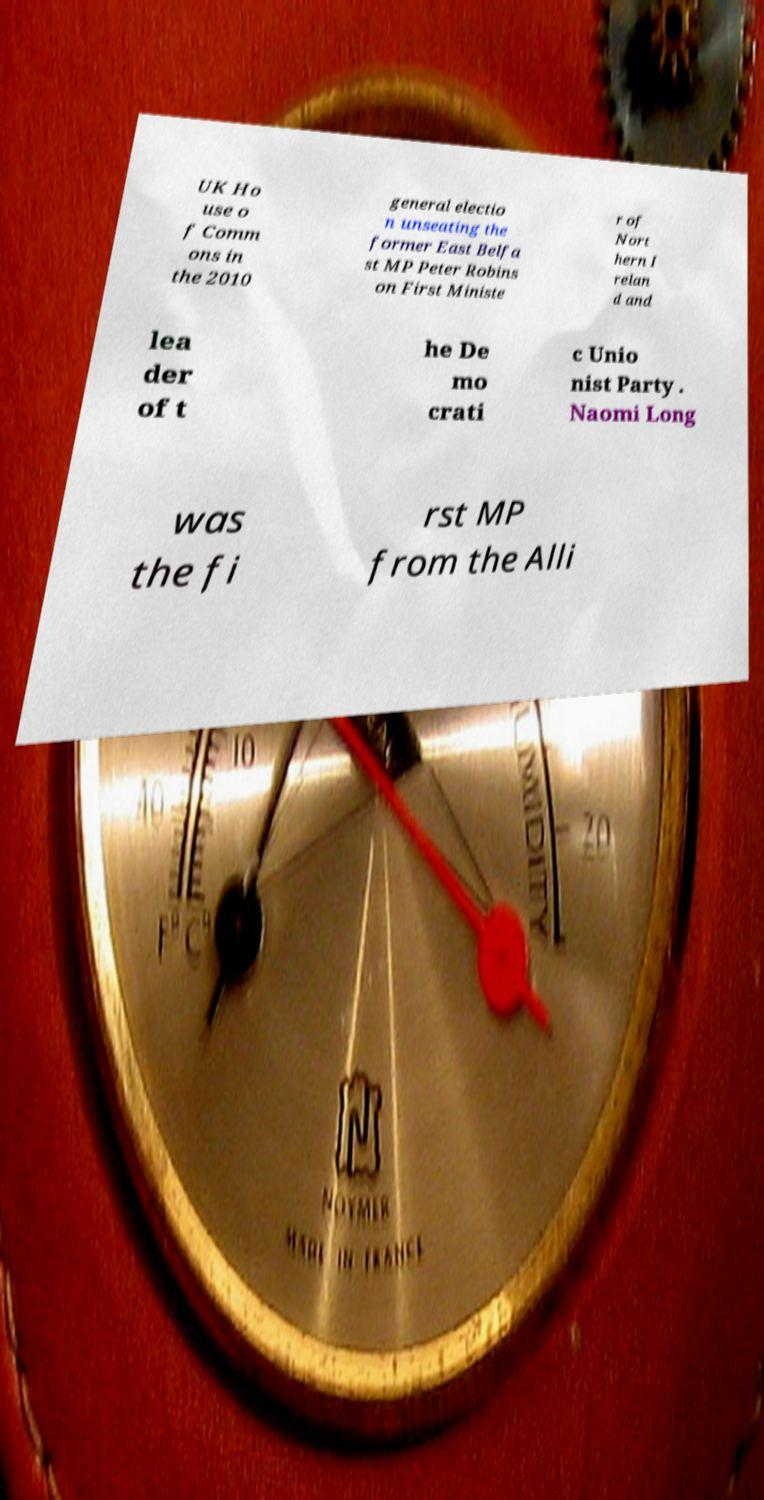Could you extract and type out the text from this image? UK Ho use o f Comm ons in the 2010 general electio n unseating the former East Belfa st MP Peter Robins on First Ministe r of Nort hern I relan d and lea der of t he De mo crati c Unio nist Party . Naomi Long was the fi rst MP from the Alli 